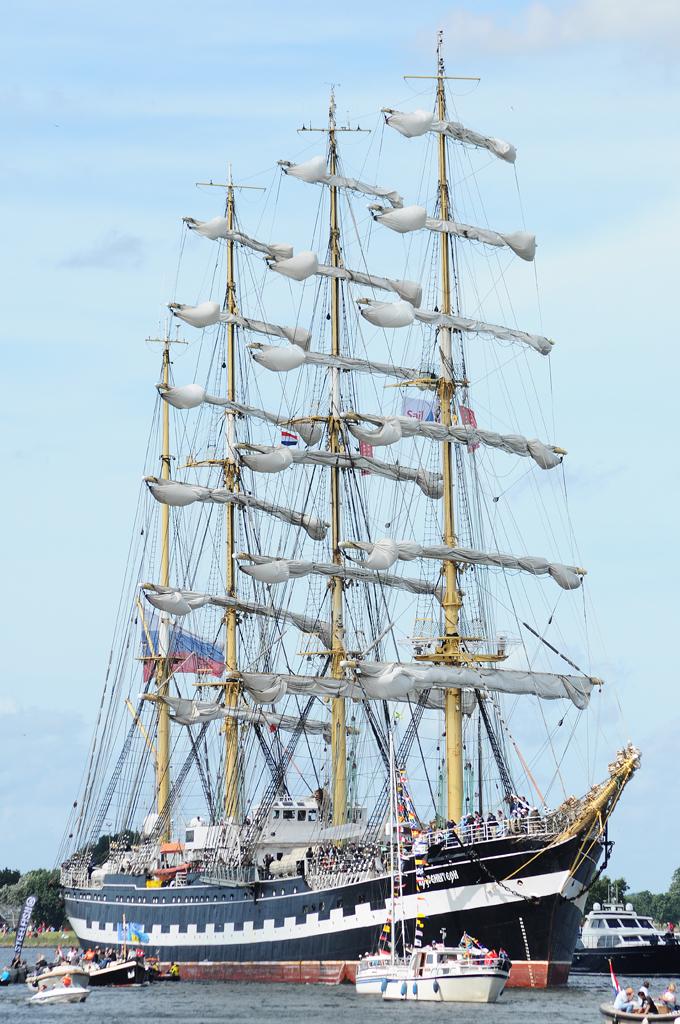What word is written in red font on the banner on this ship's front sail?
Make the answer very short. Sail. 